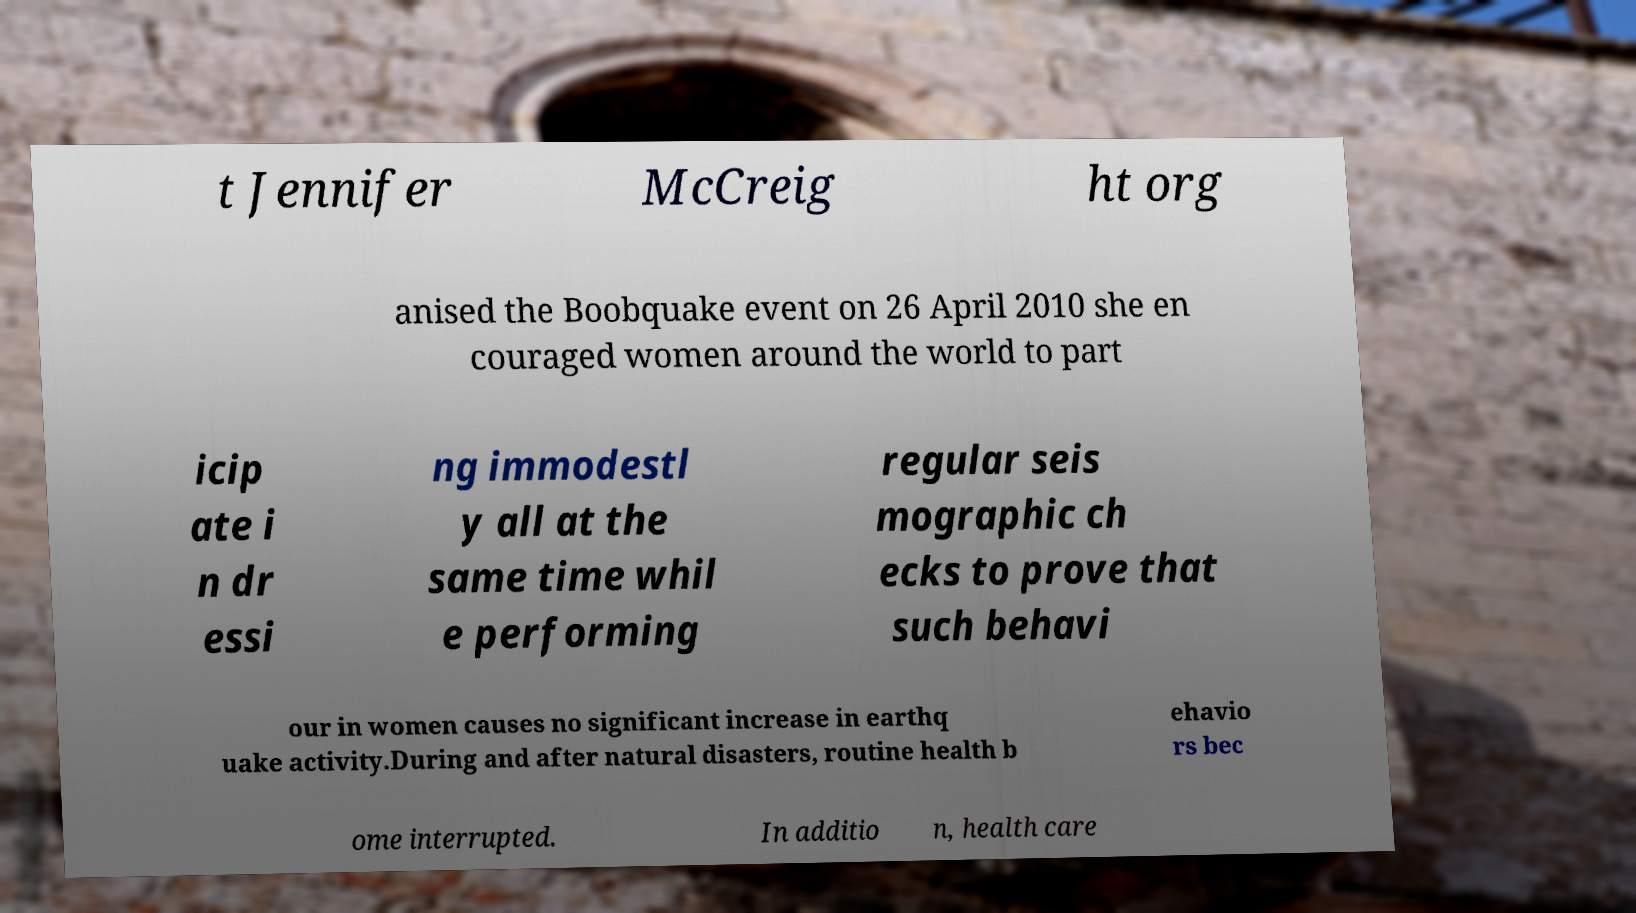There's text embedded in this image that I need extracted. Can you transcribe it verbatim? t Jennifer McCreig ht org anised the Boobquake event on 26 April 2010 she en couraged women around the world to part icip ate i n dr essi ng immodestl y all at the same time whil e performing regular seis mographic ch ecks to prove that such behavi our in women causes no significant increase in earthq uake activity.During and after natural disasters, routine health b ehavio rs bec ome interrupted. In additio n, health care 